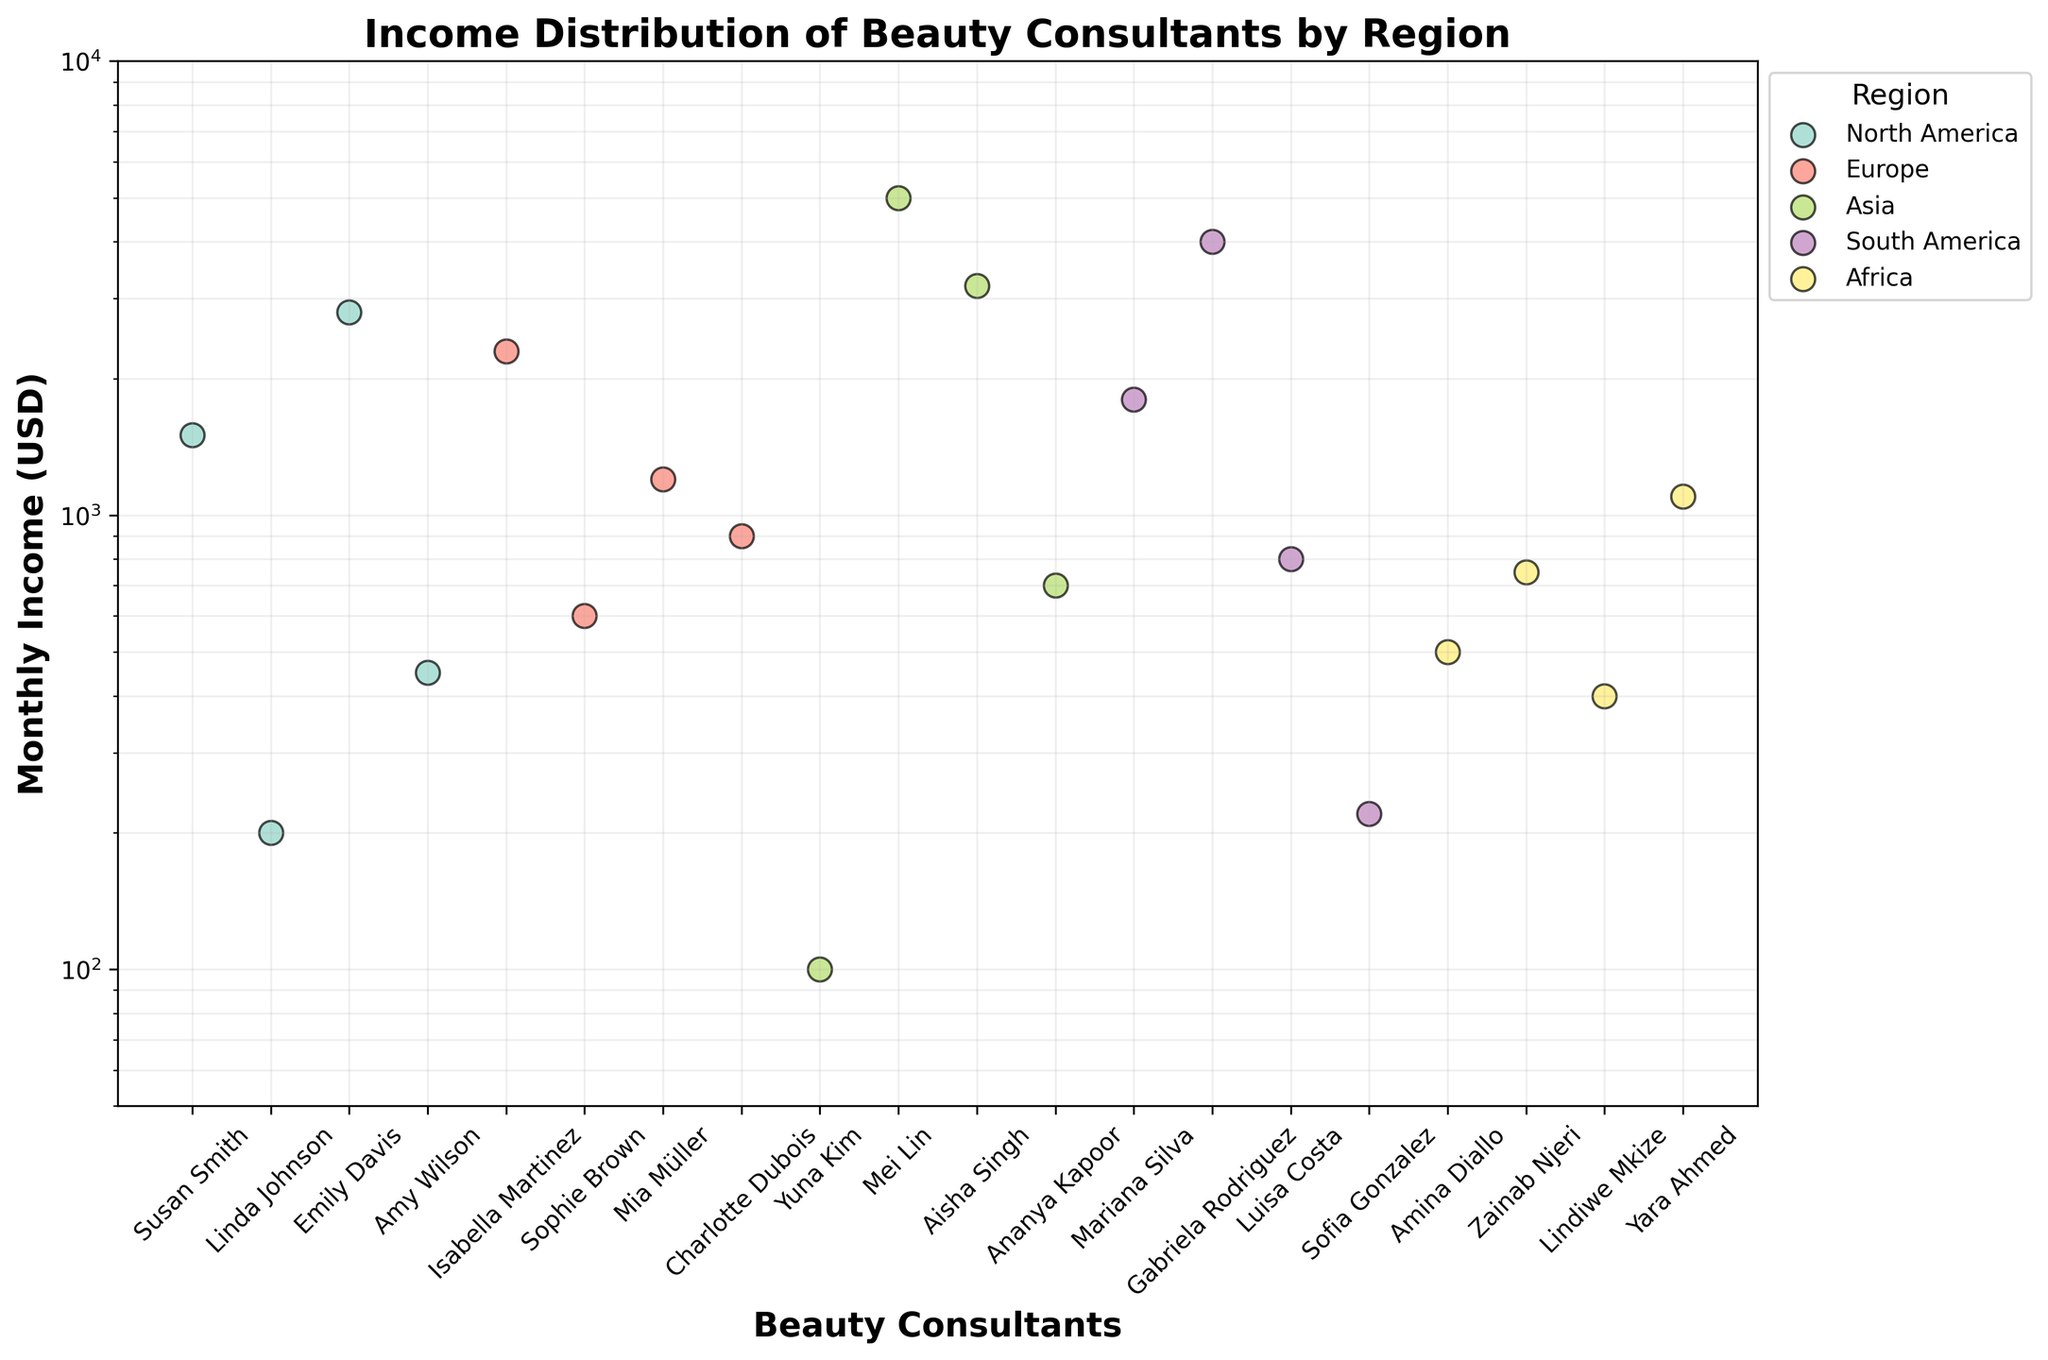What is the title of the scatter plot? The title of a plot is usually displayed at the top. In this case, it reads "Income Distribution of Beauty Consultants by Region".
Answer: Income Distribution of Beauty Consultants by Region How is the y-axis scaled in this plot? The y-axis on this scatter plot is scaled logarithmically, as indicated by the axis appearance and the provided code description.
Answer: Logarithmically Which region has the beauty consultant with the highest monthly income? By inspecting the scatter plot, the highest point on the y-axis represents the highest monthly income. This point belongs to a beauty consultant from the Asia region.
Answer: Asia How many consultants from the North America region are displayed in the plot? In the scatter plot, count the number of points labeled with consultant names under the North America category. There are four consultants from North America.
Answer: 4 Which consultant has the lowest monthly income, and which region do they belong to? The point with the lowest y-value corresponds to the lowest monthly income. This point represents Yuna Kim, who belongs to the Asia region.
Answer: Yuna Kim, Asia What is the approximate income range for consultants in the South America region? Look at the vertical spread of the points labeled under South America. The lowest point is around 200 (Sofia Gonzalez), and the highest point is around 4000 (Gabriela Rodriguez).
Answer: 200 - 4000 Who has a higher monthly income, Mariana Silva from South America or Isabella Martinez from Europe? Compare the vertical positions of Mariana Silva and Isabella Martinez. Mariana Silva's point is around 1800, while Isabella Martinez's point is around 2300. Thus, Isabella Martinez has a higher monthly income.
Answer: Isabella Martinez Which region has the most consistently high incomes, based on the spread of the data points? Consistency in high income can be seen in regions where data points are vertically higher and closely packed. Asia shows such a pattern with most incomes significantly above other regions.
Answer: Asia What is a common trait among consultants with incomes close to 1000? Identify the data points around the 1000 mark on the log scale. Regions like Africa, Europe, and South America have consultants around this income level.
Answer: Africa, Europe, and South America Can you identify if there's any consultant with the same income from different regions? By visually comparing the vertical positions of data points across regions, no two data points from different regions align perfectly at the same income value.
Answer: No 